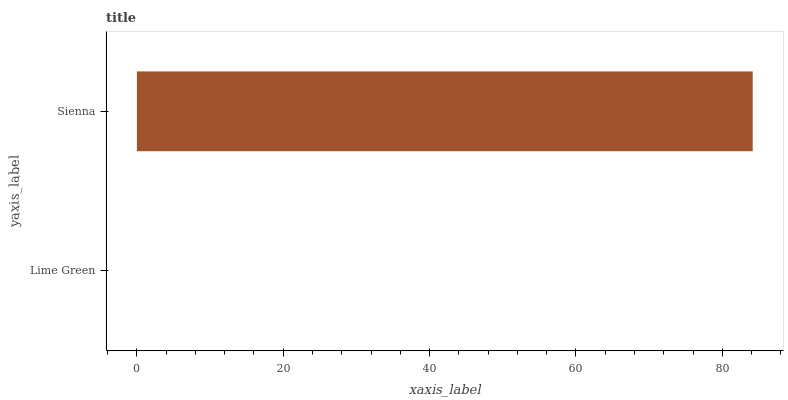Is Lime Green the minimum?
Answer yes or no. Yes. Is Sienna the maximum?
Answer yes or no. Yes. Is Sienna the minimum?
Answer yes or no. No. Is Sienna greater than Lime Green?
Answer yes or no. Yes. Is Lime Green less than Sienna?
Answer yes or no. Yes. Is Lime Green greater than Sienna?
Answer yes or no. No. Is Sienna less than Lime Green?
Answer yes or no. No. Is Sienna the high median?
Answer yes or no. Yes. Is Lime Green the low median?
Answer yes or no. Yes. Is Lime Green the high median?
Answer yes or no. No. Is Sienna the low median?
Answer yes or no. No. 